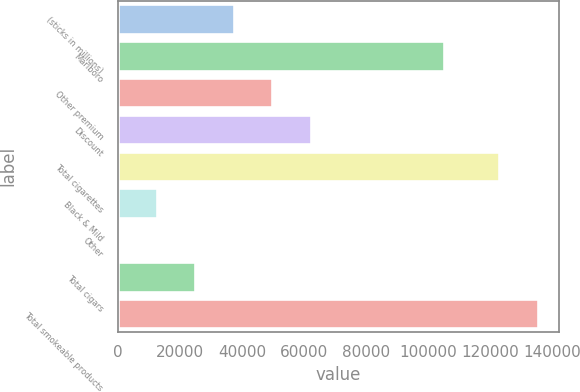Convert chart. <chart><loc_0><loc_0><loc_500><loc_500><bar_chart><fcel>(sticks in millions)<fcel>Marlboro<fcel>Other premium<fcel>Discount<fcel>Total cigarettes<fcel>Black & Mild<fcel>Other<fcel>Total cigars<fcel>Total smokeable products<nl><fcel>37316.7<fcel>105297<fcel>49747.6<fcel>62178.5<fcel>122930<fcel>12454.9<fcel>24<fcel>24885.8<fcel>135361<nl></chart> 